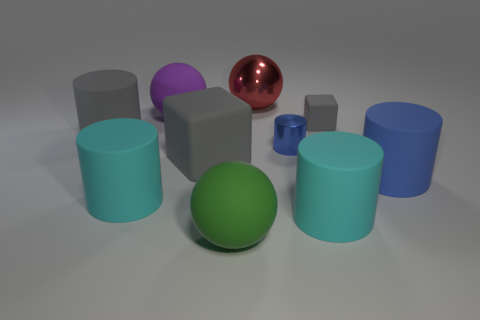Is the color of the metal object that is in front of the large purple rubber sphere the same as the rubber cylinder to the right of the tiny rubber object?
Give a very brief answer. Yes. Is there anything else of the same color as the tiny shiny cylinder?
Your response must be concise. Yes. Are there any gray objects of the same size as the metallic cylinder?
Your answer should be very brief. Yes. What is the color of the other small object that is the same material as the red object?
Give a very brief answer. Blue. What is the large blue thing made of?
Your answer should be compact. Rubber. What shape is the large purple thing?
Offer a very short reply. Sphere. What number of tiny rubber things have the same color as the big shiny thing?
Your answer should be very brief. 0. What is the material of the big cylinder behind the blue matte cylinder in front of the large matte cylinder that is behind the big blue rubber thing?
Keep it short and to the point. Rubber. How many cyan objects are either cubes or tiny rubber cubes?
Your answer should be very brief. 0. What is the size of the blue cylinder behind the large blue thing in front of the blue thing to the left of the small rubber block?
Keep it short and to the point. Small. 